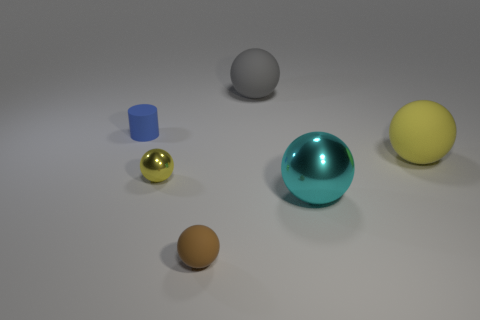The shiny ball that is behind the cyan metallic object is what color?
Your response must be concise. Yellow. There is a yellow object right of the matte object that is behind the blue cylinder; how big is it?
Ensure brevity in your answer.  Large. There is a thing behind the blue matte cylinder; does it have the same shape as the tiny blue thing?
Your answer should be very brief. No. What is the material of the big yellow thing that is the same shape as the big cyan shiny object?
Keep it short and to the point. Rubber. What number of things are objects that are right of the tiny brown sphere or yellow things to the right of the big gray object?
Your answer should be compact. 3. There is a small cylinder; is it the same color as the large ball that is in front of the yellow metal object?
Your answer should be very brief. No. There is a gray thing that is made of the same material as the tiny brown sphere; what is its shape?
Provide a succinct answer. Sphere. What number of green metal cubes are there?
Your answer should be compact. 0. How many things are either objects that are on the left side of the brown matte object or large cyan metallic things?
Your response must be concise. 3. Is the color of the ball that is in front of the cyan metallic object the same as the small cylinder?
Make the answer very short. No. 